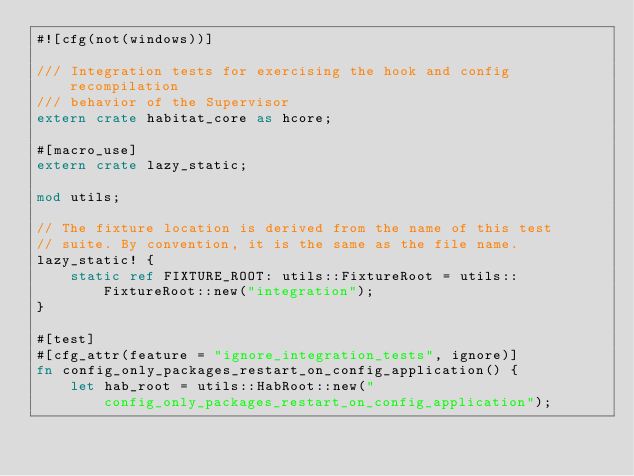Convert code to text. <code><loc_0><loc_0><loc_500><loc_500><_Rust_>#![cfg(not(windows))]

/// Integration tests for exercising the hook and config recompilation
/// behavior of the Supervisor
extern crate habitat_core as hcore;

#[macro_use]
extern crate lazy_static;

mod utils;

// The fixture location is derived from the name of this test
// suite. By convention, it is the same as the file name.
lazy_static! {
    static ref FIXTURE_ROOT: utils::FixtureRoot = utils::FixtureRoot::new("integration");
}

#[test]
#[cfg_attr(feature = "ignore_integration_tests", ignore)]
fn config_only_packages_restart_on_config_application() {
    let hab_root = utils::HabRoot::new("config_only_packages_restart_on_config_application");
</code> 